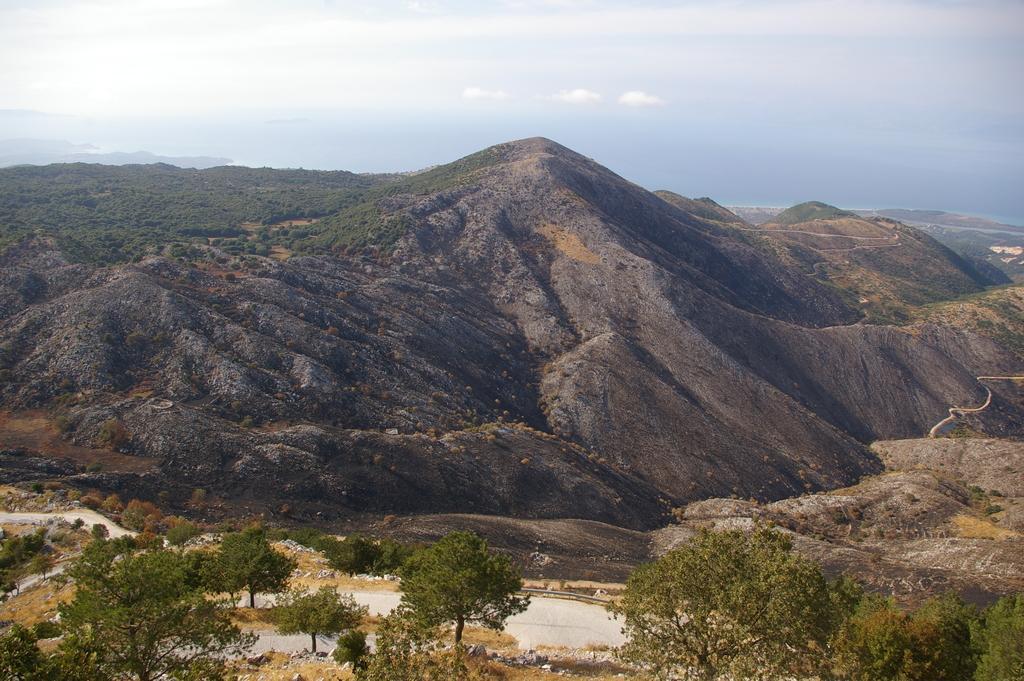Please provide a concise description of this image. In this image at the bottom there are some trees and sand, and in the background there are some mountains. On the top of the image there is sky. 